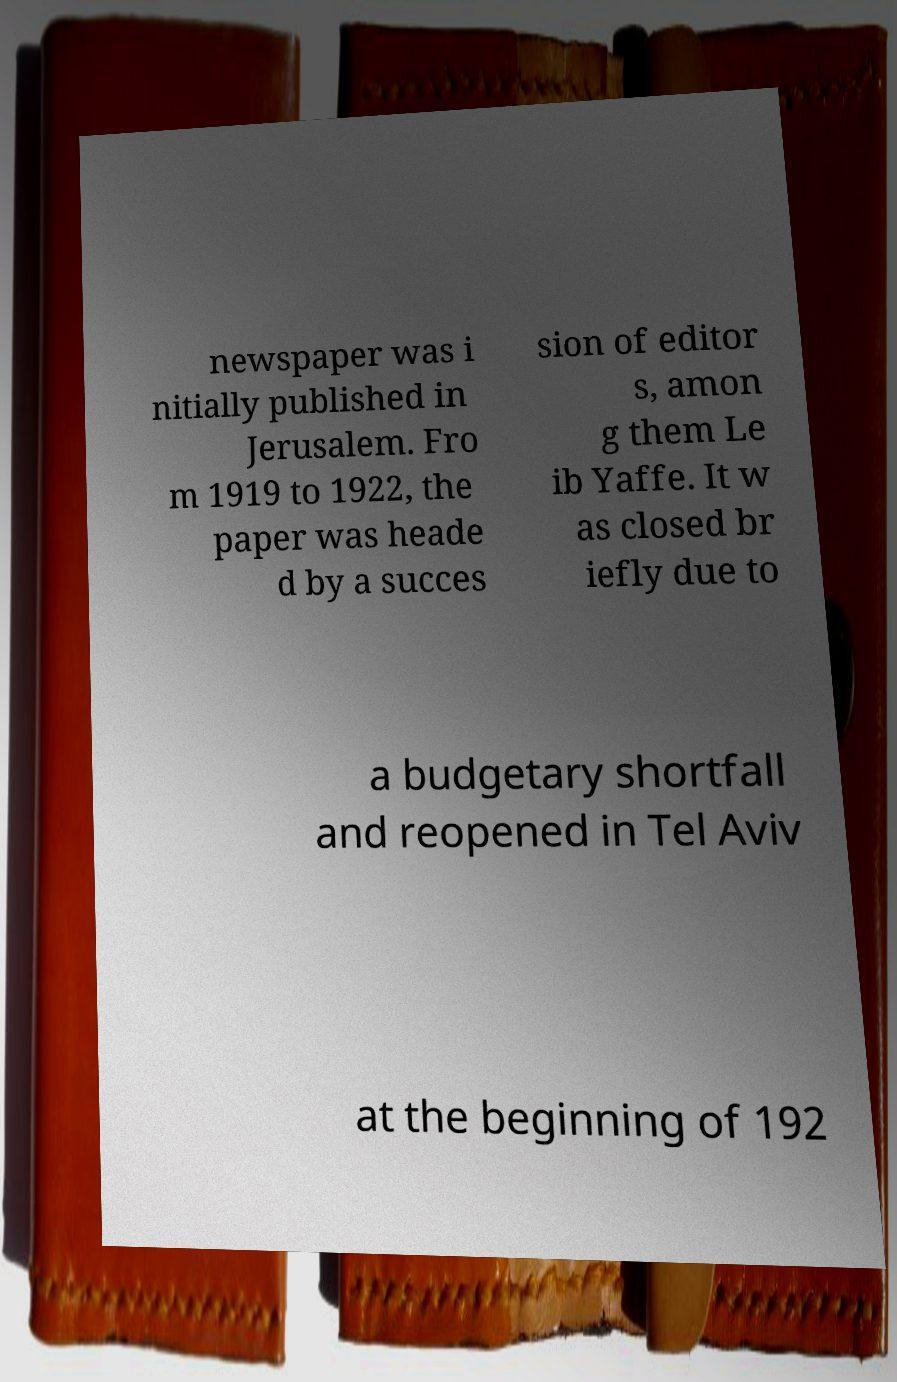What messages or text are displayed in this image? I need them in a readable, typed format. newspaper was i nitially published in Jerusalem. Fro m 1919 to 1922, the paper was heade d by a succes sion of editor s, amon g them Le ib Yaffe. It w as closed br iefly due to a budgetary shortfall and reopened in Tel Aviv at the beginning of 192 